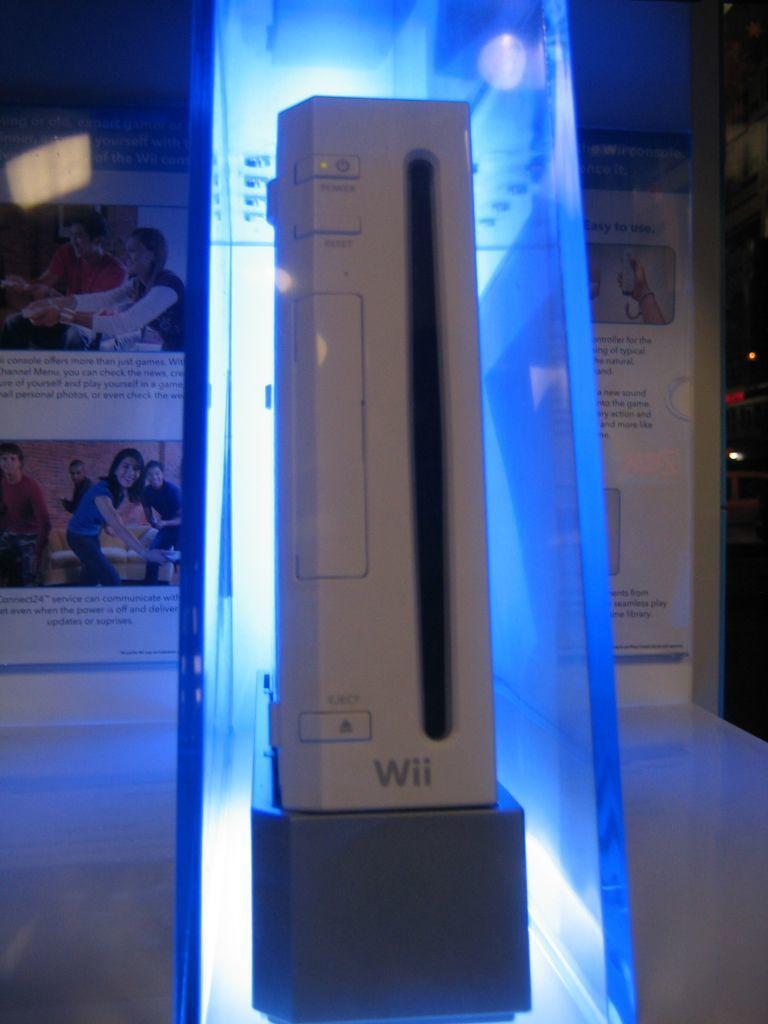Describe this image in one or two sentences. In this image we can a see a white colored object placed in the glass. In the background we can see poster. 